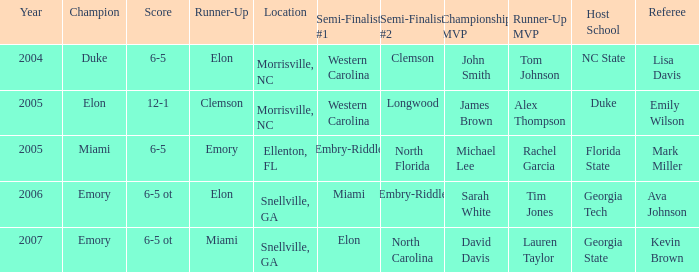When Embry-Riddle made it to the first semi finalist slot, list all the runners up. Emory. 